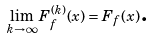<formula> <loc_0><loc_0><loc_500><loc_500>\lim _ { k \rightarrow \infty } F _ { f } ^ { ( k ) } ( x ) = F _ { f } ( x ) \text {.}</formula> 